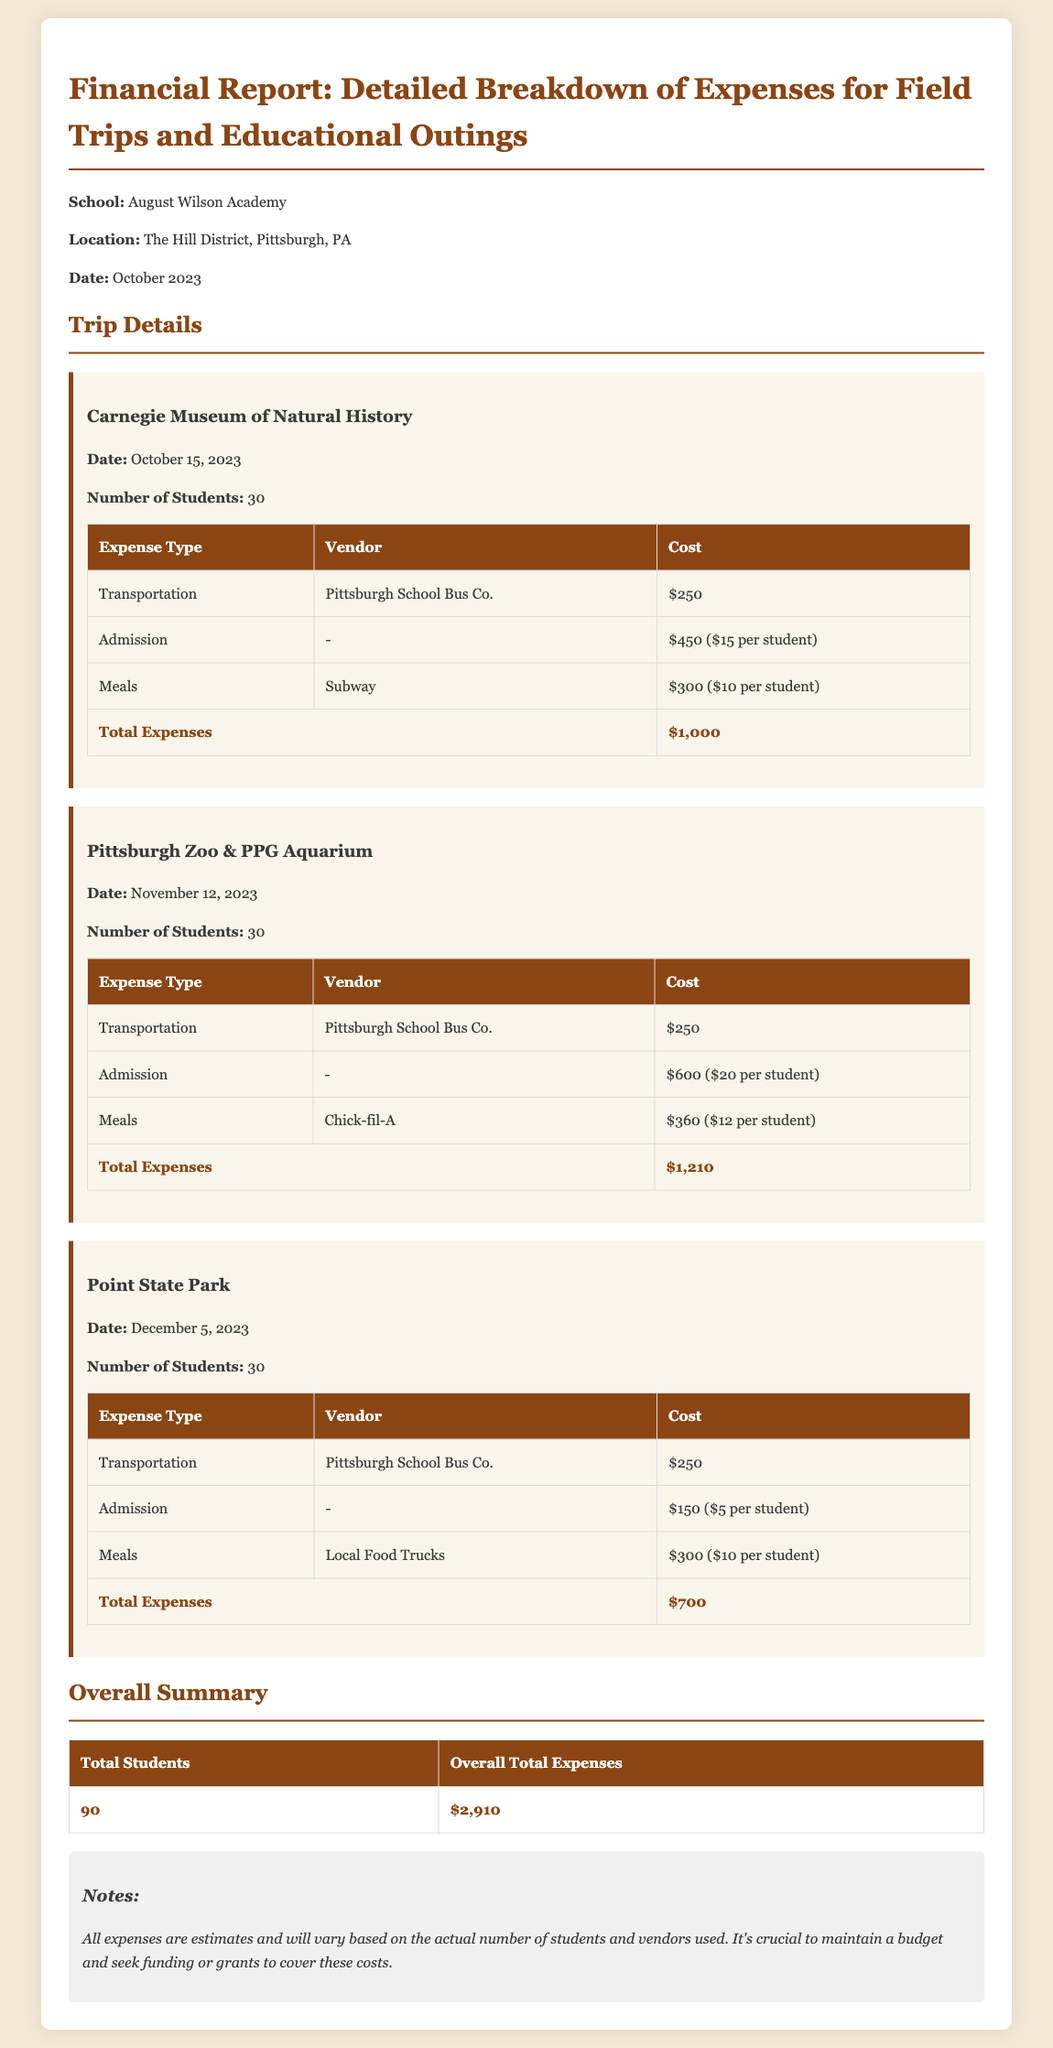what is the total number of students? The total number of students is the sum of all students attending each trip, which is 30 + 30 + 30 = 90.
Answer: 90 what is the total cost for the Carnegie Museum of Natural History trip? The total cost for the Carnegie Museum of Natural History trip is $1,000 as listed in the report.
Answer: $1,000 who provided the transportation for the Pittsburgh Zoo & PPG Aquarium trip? The vendor for transportation in the report is listed as Pittsburgh School Bus Co.
Answer: Pittsburgh School Bus Co what is the date of the Point State Park trip? The date of the Point State Park trip is specified as December 5, 2023, in the document.
Answer: December 5, 2023 how much was spent on meals for the Carnegie Museum of Natural History trip? The amount spent on meals for the Carnegie Museum of Natural History trip is mentioned as $300.
Answer: $300 what is the total overall expenses for all trips? The overall total expenses for all trips calculated in the report is $2,910.
Answer: $2,910 which vendor provided meals for the Pittsburgh Zoo & PPG Aquarium trip? The report specifies that Chick-fil-A provided meals for the Pittsburgh Zoo & PPG Aquarium trip.
Answer: Chick-fil-A what type of report is presented in this document? The report is a financial report detailing expenses for educational outings, as described in the title.
Answer: financial report 